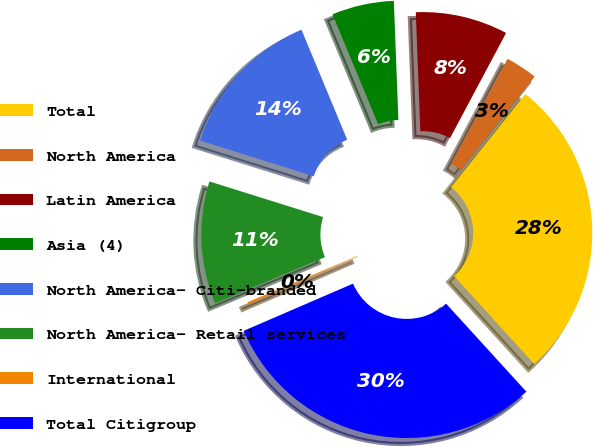Convert chart to OTSL. <chart><loc_0><loc_0><loc_500><loc_500><pie_chart><fcel>Total<fcel>North America<fcel>Latin America<fcel>Asia (4)<fcel>North America- Citi-branded<fcel>North America- Retail services<fcel>International<fcel>Total Citigroup<nl><fcel>27.53%<fcel>2.91%<fcel>8.4%<fcel>5.66%<fcel>13.9%<fcel>11.15%<fcel>0.17%<fcel>30.28%<nl></chart> 